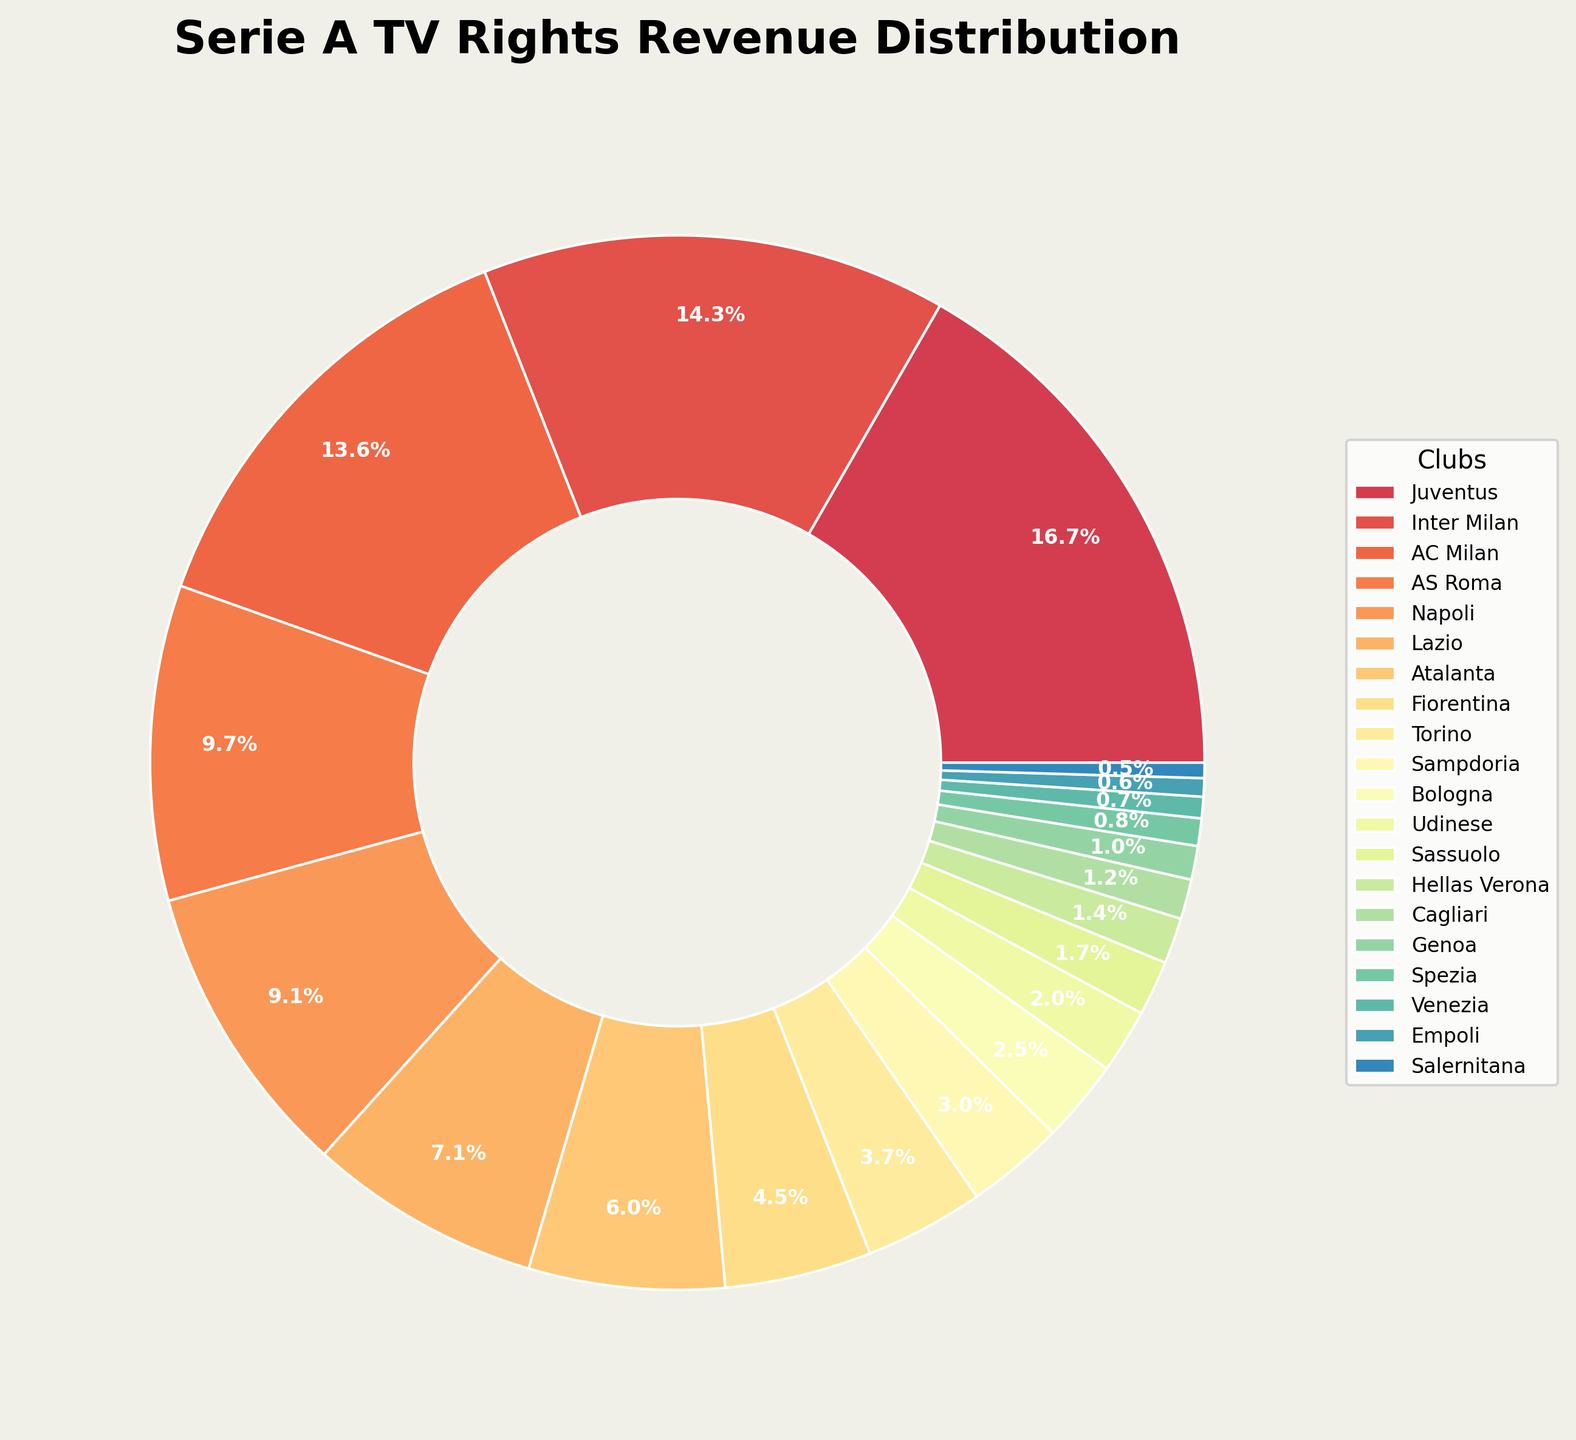Which club has the highest share of TV rights revenue? The largest wedge in the pie chart belongs to Juventus.
Answer: Juventus Which club has the lowest share of TV rights revenue? The smallest wedge in the pie chart belongs to Salernitana.
Answer: Salernitana What is the combined TV rights revenue share of Juventus, Inter Milan, and AC Milan? Add the percentages for Juventus (17.8%), Inter Milan (15.2%), and AC Milan (14.5%): 17.8 + 15.2 + 14.5 = 47.5%
Answer: 47.5% Which clubs have a revenue share higher than 10%? Clubs with wedges larger than 10% include Juventus (17.8%), Inter Milan (15.2%), AC Milan (14.5%), and AS Roma (10.3%).
Answer: Juventus, Inter Milan, AC Milan, AS Roma How does the revenue share of Napoli compare to Lazio? Napoli has a revenue share of 9.7%, while Lazio has 7.6%. Since 9.7% > 7.6%, Napoli has a higher share.
Answer: Napoli has a higher share What is the visual difference in size between the wedges for Fiorentina and Torino? Fiorentina's wedge is larger than Torino's due to their revenue share being 4.8% compared to Torino's 3.9%.
Answer: Fiorentina has a larger wedge If you sum the revenue shares of all clubs except the top five, what percentage do you get? Excluding the top five clubs: 100 - (17.8 + 15.2 + 14.5 + 10.3 + 9.7) = 100 - 67.5 = 32.5%
Answer: 32.5% Which clubs are closest in revenue share, and how much is the difference? Sassuolo (1.8%) and Hellas Verona (1.5%) are close, with a difference of 1.8 - 1.5 = 0.3%.
Answer: Sassuolo and Hellas Verona, 0.3% How does the share of the largest club compare to the smallest club in terms of magnitude? The ratio of Juventus' share (17.8%) to Salernitana's share (0.5%) is 17.8 / 0.5 = 35.6 times.
Answer: 35.6 times Are there more clubs with revenue shares above or below 5%? Seven clubs have shares above 5% and thirteen below 5%.
Answer: More clubs below 5% 